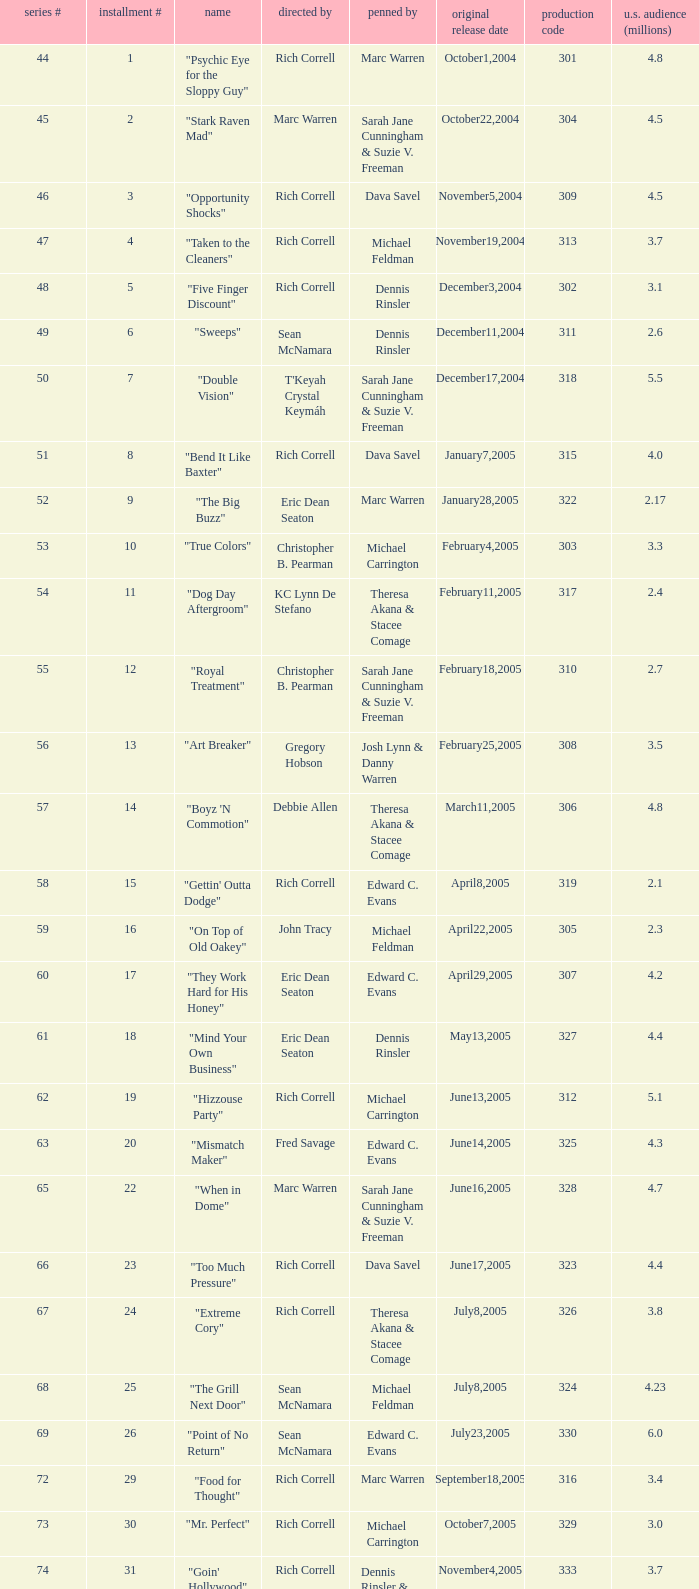What was the production code of the episode directed by Rondell Sheridan?  332.0. 